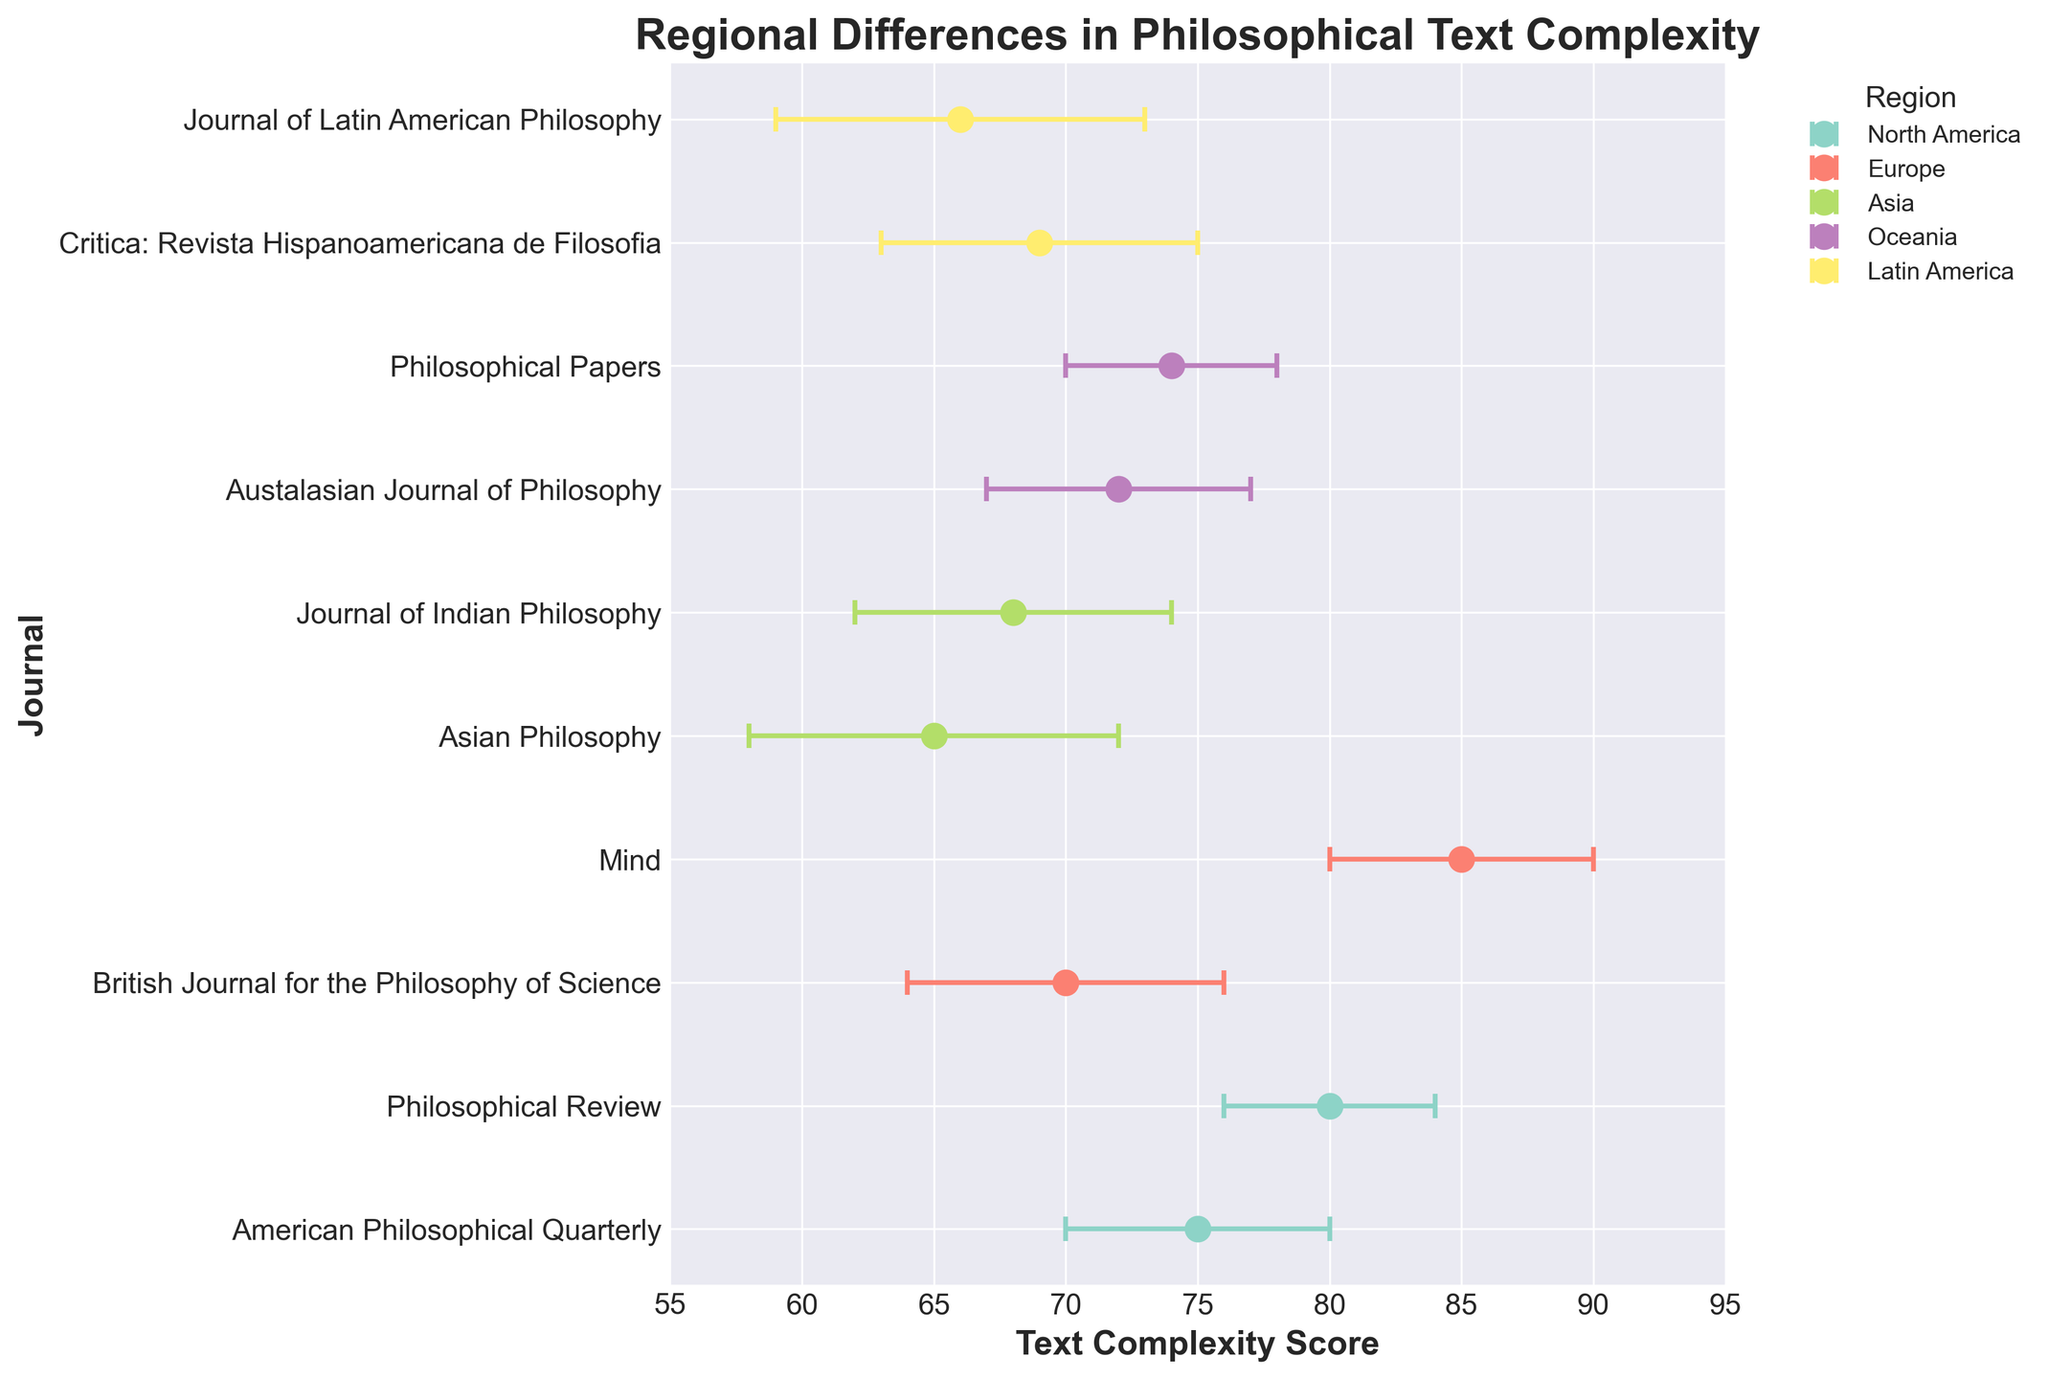What is the title of the plot? The title of the plot is usually displayed at the top center of a figure. By reading the text in this position, one can see that the title is "Regional Differences in Philosophical Text Complexity".
Answer: Regional Differences in Philosophical Text Complexity What are the regions with the highest and lowest text complexity scores? Identify the highest and lowest points on the horizontal axis (Text Complexity Score) and refer to the respective labeled journals and their associated regions. The highest score is 85 by Mind in Europe, and the lowest score is 65 by Asian Philosophy in Asia.
Answer: Europe (highest), Asia (lowest) How many journals are analyzed in total? Count the number of unique points or markers on the plot, as each marker represents a journal.
Answer: 10 What is the average text complexity score for journals from North America? Sum the text complexity scores of the journals from North America (75 and 80), then divide by the number of journals (2). (75 + 80) / 2 = 77.5
Answer: 77.5 Which journal in Oceania has a higher text complexity score, and by how much? Compare the scores of the journals in Oceania. The Austalasian Journal of Philosophy has a score of 72, and Philosophical Papers has a score of 74. Calculate the difference between these two scores: 74 - 72 = 2.
Answer: Philosophical Papers by 2 Which region demonstrates the widest range of text complexity scores? Determine the range by finding the difference between the highest and lowest scores within each region. Calculate for each region and compare. North America's range: 80 - 75 = 5, Europe's range: 85 - 70 = 15, Asia's range: 68 - 65 = 3, Oceania's range: 74 - 72 = 2, Latin America's range: 69 - 66 = 3. Europe has the widest range of 15.
Answer: Europe What is the standard error for the text complexity score of Mind in Europe? Find the error bars associated with the "Mind" journal. The standard error for Mind, located in Europe, is 5 as stated in the data.
Answer: 5 Comparing the standard errors, which region shows the most consistency (smallest standard error) in its text complexity scores? Review the standard errors listed for each region and identify the smallest value in each group of journals. North America: 4 and 5, Europe: 5 and 6, Asia: 6 and 7, Oceania: 4 and 5, Latin America: 6 and 7. Oceania shows the smallest maximum standard error of 5.
Answer: Oceania What might indicate a high variability in text complexity scores among journals within a region? High variability can be indicated by large standard errors and a wide range of text complexity scores. Evaluate the range and standard errors for each region to determine where variability is highest. Europe has the widest range and relatively high standard errors (5 and 6).
Answer: Large standard errors and wide range in Europe 